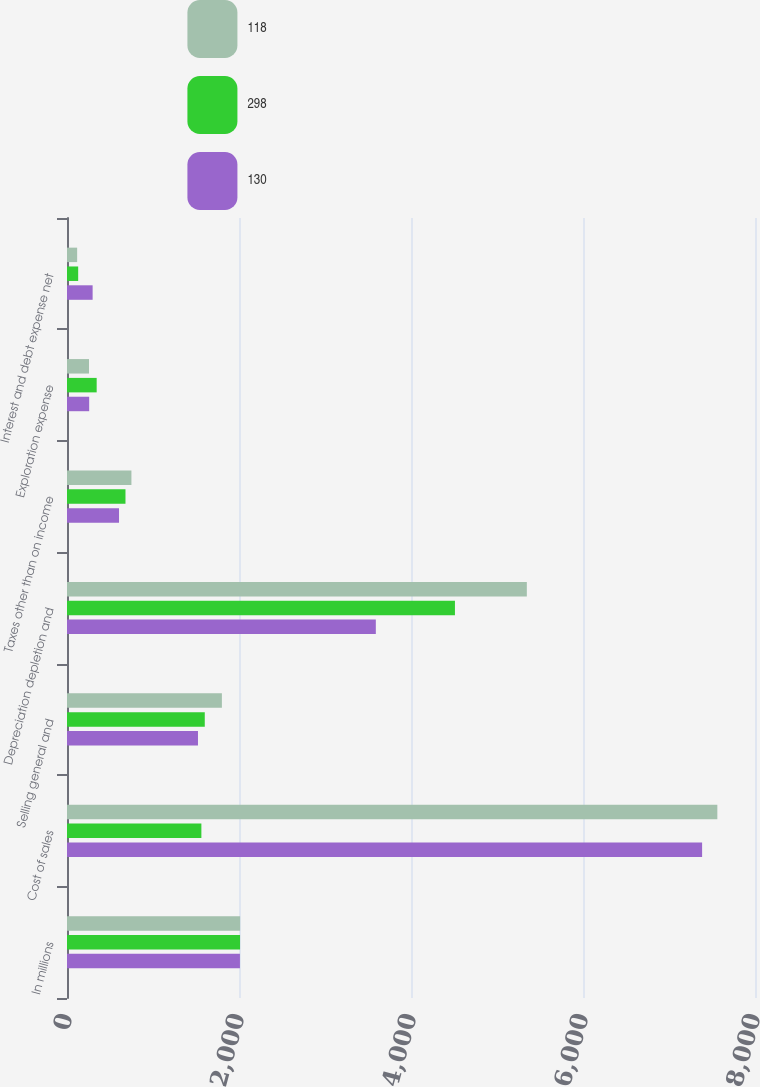Convert chart. <chart><loc_0><loc_0><loc_500><loc_500><stacked_bar_chart><ecel><fcel>In millions<fcel>Cost of sales<fcel>Selling general and<fcel>Depreciation depletion and<fcel>Taxes other than on income<fcel>Exploration expense<fcel>Interest and debt expense net<nl><fcel>118<fcel>2013<fcel>7562<fcel>1801<fcel>5347<fcel>749<fcel>256<fcel>118<nl><fcel>298<fcel>2012<fcel>1562.5<fcel>1602<fcel>4511<fcel>680<fcel>345<fcel>130<nl><fcel>130<fcel>2011<fcel>7385<fcel>1523<fcel>3591<fcel>605<fcel>258<fcel>298<nl></chart> 